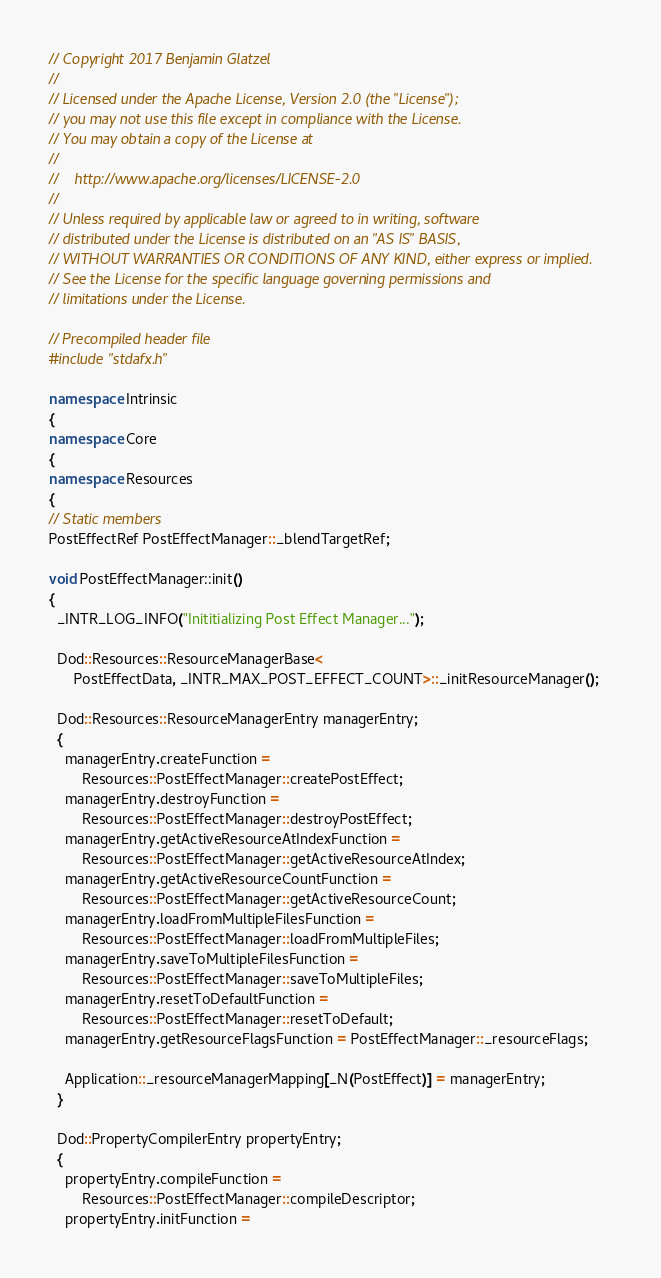<code> <loc_0><loc_0><loc_500><loc_500><_C++_>// Copyright 2017 Benjamin Glatzel
//
// Licensed under the Apache License, Version 2.0 (the "License");
// you may not use this file except in compliance with the License.
// You may obtain a copy of the License at
//
//    http://www.apache.org/licenses/LICENSE-2.0
//
// Unless required by applicable law or agreed to in writing, software
// distributed under the License is distributed on an "AS IS" BASIS,
// WITHOUT WARRANTIES OR CONDITIONS OF ANY KIND, either express or implied.
// See the License for the specific language governing permissions and
// limitations under the License.

// Precompiled header file
#include "stdafx.h"

namespace Intrinsic
{
namespace Core
{
namespace Resources
{
// Static members
PostEffectRef PostEffectManager::_blendTargetRef;

void PostEffectManager::init()
{
  _INTR_LOG_INFO("Inititializing Post Effect Manager...");

  Dod::Resources::ResourceManagerBase<
      PostEffectData, _INTR_MAX_POST_EFFECT_COUNT>::_initResourceManager();

  Dod::Resources::ResourceManagerEntry managerEntry;
  {
    managerEntry.createFunction =
        Resources::PostEffectManager::createPostEffect;
    managerEntry.destroyFunction =
        Resources::PostEffectManager::destroyPostEffect;
    managerEntry.getActiveResourceAtIndexFunction =
        Resources::PostEffectManager::getActiveResourceAtIndex;
    managerEntry.getActiveResourceCountFunction =
        Resources::PostEffectManager::getActiveResourceCount;
    managerEntry.loadFromMultipleFilesFunction =
        Resources::PostEffectManager::loadFromMultipleFiles;
    managerEntry.saveToMultipleFilesFunction =
        Resources::PostEffectManager::saveToMultipleFiles;
    managerEntry.resetToDefaultFunction =
        Resources::PostEffectManager::resetToDefault;
    managerEntry.getResourceFlagsFunction = PostEffectManager::_resourceFlags;

    Application::_resourceManagerMapping[_N(PostEffect)] = managerEntry;
  }

  Dod::PropertyCompilerEntry propertyEntry;
  {
    propertyEntry.compileFunction =
        Resources::PostEffectManager::compileDescriptor;
    propertyEntry.initFunction =</code> 